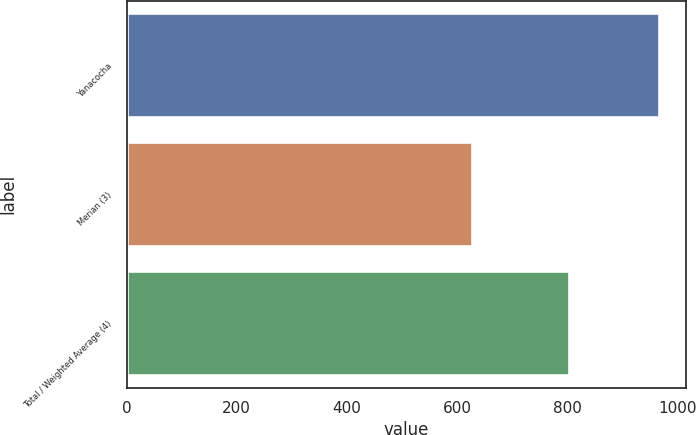Convert chart. <chart><loc_0><loc_0><loc_500><loc_500><bar_chart><fcel>Yanacocha<fcel>Merian (3)<fcel>Total / Weighted Average (4)<nl><fcel>967<fcel>627<fcel>804<nl></chart> 